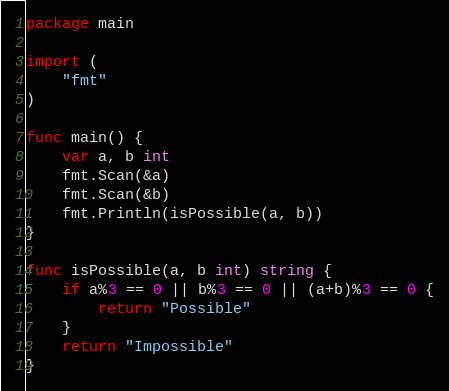Convert code to text. <code><loc_0><loc_0><loc_500><loc_500><_Go_>package main

import (
	"fmt"
)

func main() {
	var a, b int
	fmt.Scan(&a)
	fmt.Scan(&b)
	fmt.Println(isPossible(a, b))
}

func isPossible(a, b int) string {
	if a%3 == 0 || b%3 == 0 || (a+b)%3 == 0 {
		return "Possible"
	}
	return "Impossible"
}</code> 